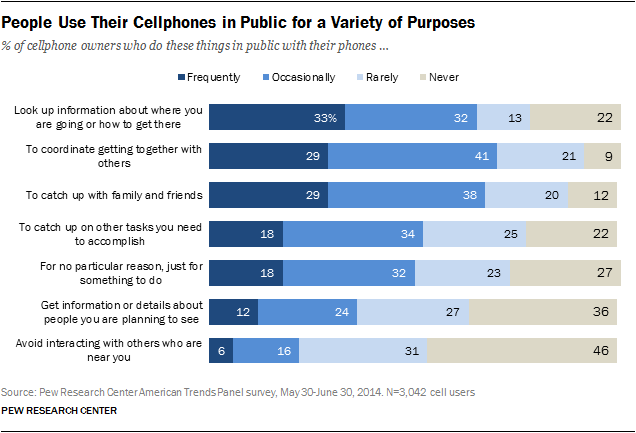Give some essential details in this illustration. The grey bar represents the value of "never". The difference between the maximum and minimum value of "Frequently" and "Never" respectively, when rated on a scale of 1 to 24, is 24. 